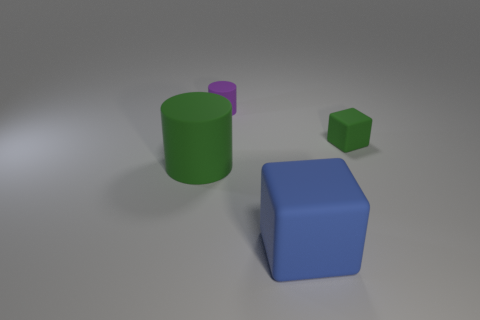Is there a small object that is in front of the green object on the right side of the large block? Indeed there is no small object located in front of the green cylinder on the right side of the large blue cube in the image. The small green cube is actually situated behind the large block when viewed from this perspective. 